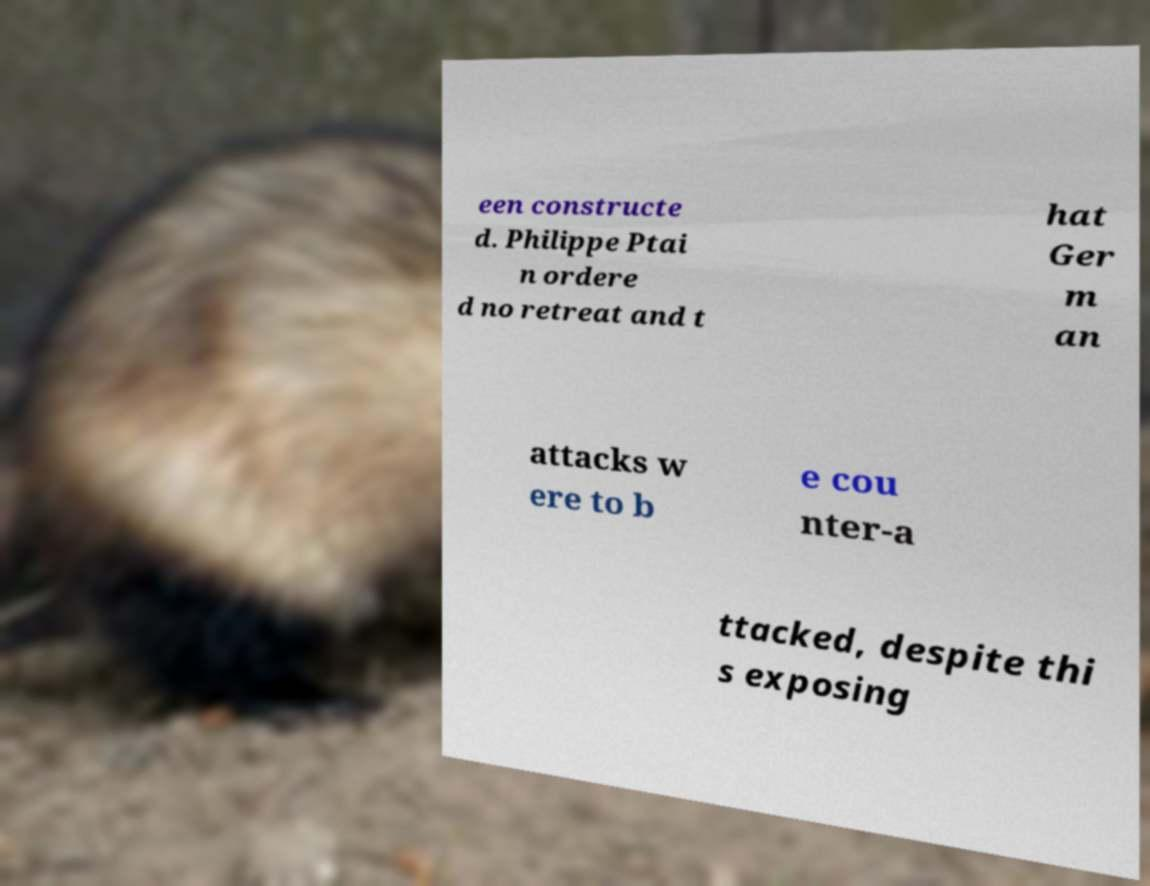Could you extract and type out the text from this image? een constructe d. Philippe Ptai n ordere d no retreat and t hat Ger m an attacks w ere to b e cou nter-a ttacked, despite thi s exposing 